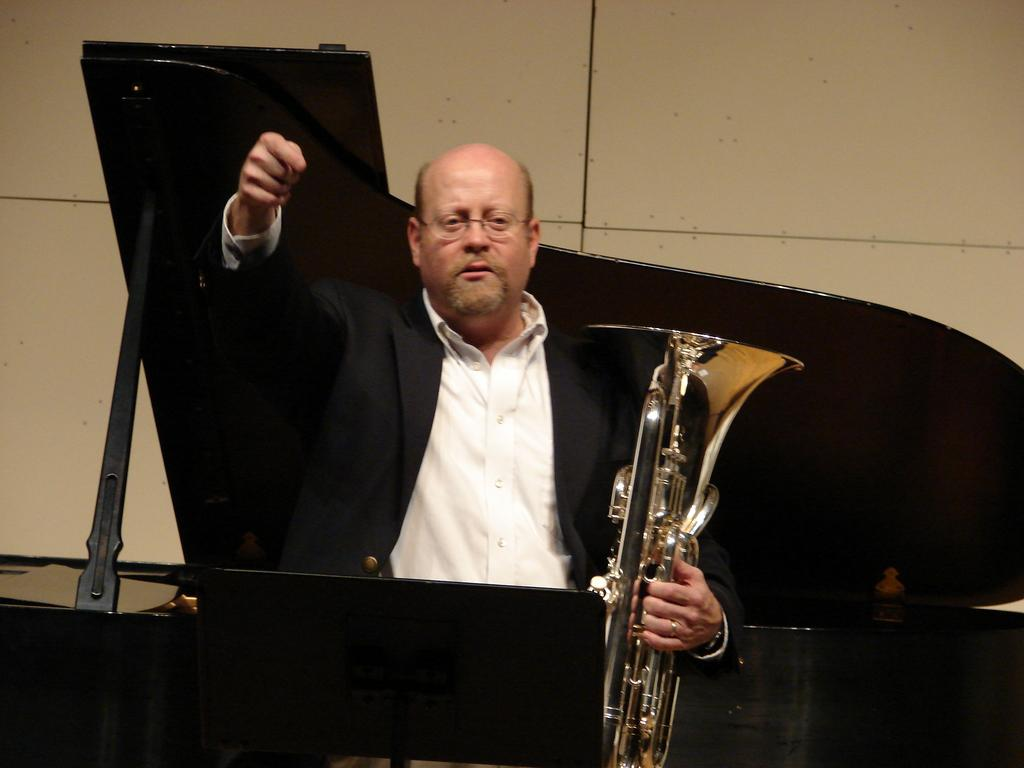Who is the main subject in the image? There is a man in the image. Where is the man positioned in the image? The man is standing in the center of the image. What is the man holding in his hand? The man is holding a trumpet in his hand. What instrument is in front of the man? There is a piano in front of the man. Can you see any rabbits or cows participating in the musical activity in the image? There are no rabbits or cows present in the image, and no musical activity involving animals is depicted. 